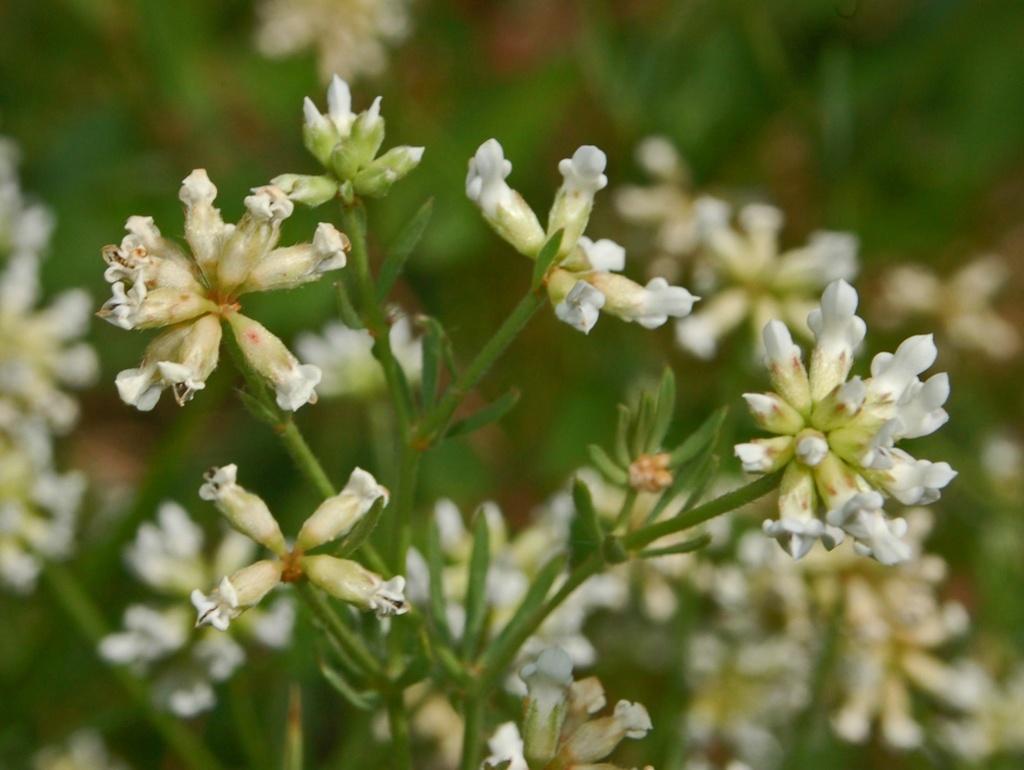Please provide a concise description of this image. In this image we can see a plant with some bunch of flowers to it. 